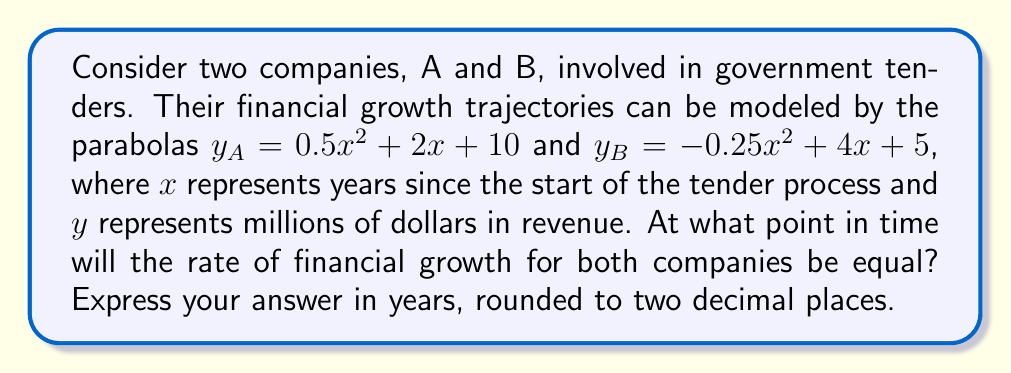Help me with this question. To solve this problem, we need to follow these steps:

1) The rate of financial growth at any point is represented by the slope of the tangent line to the parabola at that point. This slope is given by the first derivative of the function.

2) For Company A: 
   $y_A = 0.5x^2 + 2x + 10$
   $\frac{dy_A}{dx} = x + 2$

3) For Company B:
   $y_B = -0.25x^2 + 4x + 5$
   $\frac{dy_B}{dx} = -0.5x + 4$

4) The rates of growth will be equal when these derivatives are equal:
   $x + 2 = -0.5x + 4$

5) Solve this equation:
   $x + 2 = -0.5x + 4$
   $1.5x = 2$
   $x = \frac{4}{3} \approx 1.33$

6) To verify, we can calculate the growth rates at this point:
   For A: $1.33 + 2 = 3.33$
   For B: $-0.5(1.33) + 4 = 3.33$

Therefore, the rates of financial growth for both companies will be equal after approximately 1.33 years.
Answer: 1.33 years 